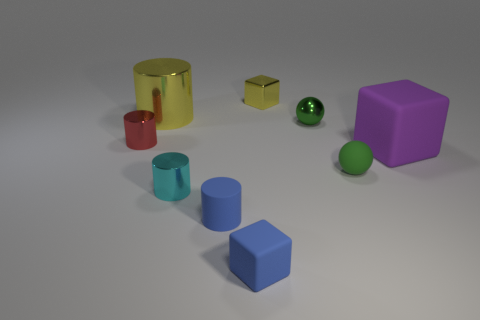Subtract all purple spheres. Subtract all blue cubes. How many spheres are left? 2 Add 1 small metal cubes. How many objects exist? 10 Subtract all cubes. How many objects are left? 6 Add 7 large gray rubber cubes. How many large gray rubber cubes exist? 7 Subtract 0 green cylinders. How many objects are left? 9 Subtract all cyan cylinders. Subtract all green rubber cylinders. How many objects are left? 8 Add 1 yellow shiny cylinders. How many yellow shiny cylinders are left? 2 